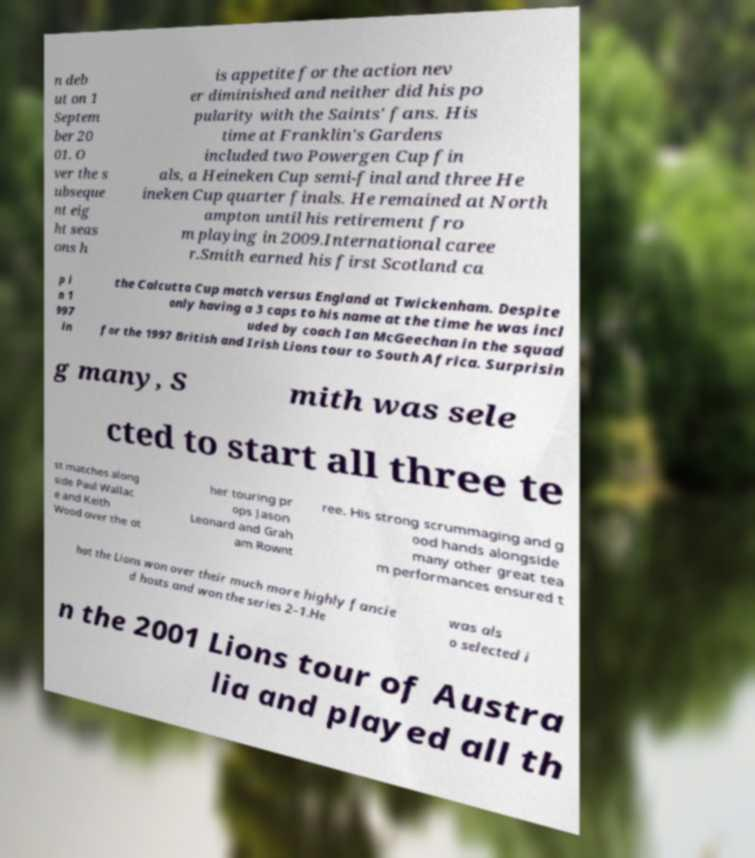Could you extract and type out the text from this image? n deb ut on 1 Septem ber 20 01. O ver the s ubseque nt eig ht seas ons h is appetite for the action nev er diminished and neither did his po pularity with the Saints' fans. His time at Franklin's Gardens included two Powergen Cup fin als, a Heineken Cup semi-final and three He ineken Cup quarter finals. He remained at North ampton until his retirement fro m playing in 2009.International caree r.Smith earned his first Scotland ca p i n 1 997 in the Calcutta Cup match versus England at Twickenham. Despite only having a 3 caps to his name at the time he was incl uded by coach Ian McGeechan in the squad for the 1997 British and Irish Lions tour to South Africa. Surprisin g many, S mith was sele cted to start all three te st matches along side Paul Wallac e and Keith Wood over the ot her touring pr ops Jason Leonard and Grah am Rownt ree. His strong scrummaging and g ood hands alongside many other great tea m performances ensured t hat the Lions won over their much more highly fancie d hosts and won the series 2–1.He was als o selected i n the 2001 Lions tour of Austra lia and played all th 